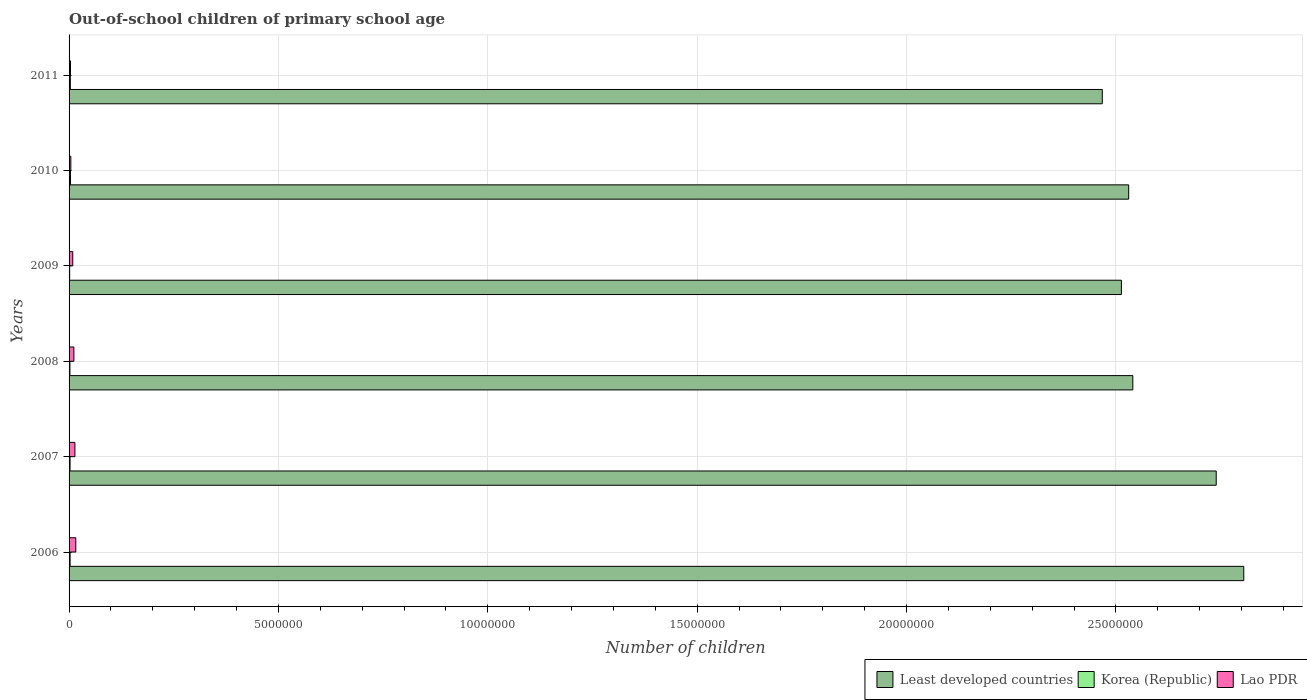Are the number of bars on each tick of the Y-axis equal?
Keep it short and to the point. Yes. How many bars are there on the 3rd tick from the bottom?
Provide a succinct answer. 3. What is the label of the 5th group of bars from the top?
Give a very brief answer. 2007. In how many cases, is the number of bars for a given year not equal to the number of legend labels?
Keep it short and to the point. 0. What is the number of out-of-school children in Korea (Republic) in 2007?
Provide a succinct answer. 2.36e+04. Across all years, what is the maximum number of out-of-school children in Korea (Republic)?
Give a very brief answer. 3.47e+04. Across all years, what is the minimum number of out-of-school children in Least developed countries?
Ensure brevity in your answer.  2.47e+07. What is the total number of out-of-school children in Least developed countries in the graph?
Keep it short and to the point. 1.56e+08. What is the difference between the number of out-of-school children in Least developed countries in 2006 and that in 2011?
Offer a terse response. 3.38e+06. What is the difference between the number of out-of-school children in Lao PDR in 2006 and the number of out-of-school children in Korea (Republic) in 2011?
Make the answer very short. 1.30e+05. What is the average number of out-of-school children in Lao PDR per year?
Make the answer very short. 9.64e+04. In the year 2006, what is the difference between the number of out-of-school children in Least developed countries and number of out-of-school children in Lao PDR?
Your answer should be very brief. 2.79e+07. In how many years, is the number of out-of-school children in Korea (Republic) greater than 22000000 ?
Provide a short and direct response. 0. What is the ratio of the number of out-of-school children in Least developed countries in 2007 to that in 2009?
Keep it short and to the point. 1.09. What is the difference between the highest and the second highest number of out-of-school children in Least developed countries?
Provide a succinct answer. 6.58e+05. What is the difference between the highest and the lowest number of out-of-school children in Least developed countries?
Your response must be concise. 3.38e+06. In how many years, is the number of out-of-school children in Korea (Republic) greater than the average number of out-of-school children in Korea (Republic) taken over all years?
Give a very brief answer. 3. What does the 1st bar from the top in 2006 represents?
Offer a very short reply. Lao PDR. Are all the bars in the graph horizontal?
Ensure brevity in your answer.  Yes. Are the values on the major ticks of X-axis written in scientific E-notation?
Offer a terse response. No. Does the graph contain any zero values?
Make the answer very short. No. Does the graph contain grids?
Your answer should be very brief. Yes. Where does the legend appear in the graph?
Offer a terse response. Bottom right. What is the title of the graph?
Your answer should be compact. Out-of-school children of primary school age. What is the label or title of the X-axis?
Ensure brevity in your answer.  Number of children. What is the Number of children in Least developed countries in 2006?
Provide a succinct answer. 2.81e+07. What is the Number of children in Korea (Republic) in 2006?
Provide a short and direct response. 2.47e+04. What is the Number of children in Lao PDR in 2006?
Provide a short and direct response. 1.61e+05. What is the Number of children of Least developed countries in 2007?
Offer a terse response. 2.74e+07. What is the Number of children of Korea (Republic) in 2007?
Keep it short and to the point. 2.36e+04. What is the Number of children in Lao PDR in 2007?
Keep it short and to the point. 1.39e+05. What is the Number of children of Least developed countries in 2008?
Ensure brevity in your answer.  2.54e+07. What is the Number of children of Korea (Republic) in 2008?
Offer a terse response. 1.99e+04. What is the Number of children of Lao PDR in 2008?
Provide a short and direct response. 1.15e+05. What is the Number of children in Least developed countries in 2009?
Your answer should be very brief. 2.51e+07. What is the Number of children in Korea (Republic) in 2009?
Make the answer very short. 1.38e+04. What is the Number of children of Lao PDR in 2009?
Give a very brief answer. 8.77e+04. What is the Number of children in Least developed countries in 2010?
Provide a short and direct response. 2.53e+07. What is the Number of children of Korea (Republic) in 2010?
Offer a terse response. 3.47e+04. What is the Number of children in Lao PDR in 2010?
Ensure brevity in your answer.  4.20e+04. What is the Number of children of Least developed countries in 2011?
Offer a very short reply. 2.47e+07. What is the Number of children in Korea (Republic) in 2011?
Provide a succinct answer. 3.04e+04. What is the Number of children of Lao PDR in 2011?
Offer a terse response. 3.39e+04. Across all years, what is the maximum Number of children of Least developed countries?
Make the answer very short. 2.81e+07. Across all years, what is the maximum Number of children in Korea (Republic)?
Give a very brief answer. 3.47e+04. Across all years, what is the maximum Number of children of Lao PDR?
Provide a succinct answer. 1.61e+05. Across all years, what is the minimum Number of children of Least developed countries?
Your answer should be very brief. 2.47e+07. Across all years, what is the minimum Number of children of Korea (Republic)?
Offer a very short reply. 1.38e+04. Across all years, what is the minimum Number of children of Lao PDR?
Provide a succinct answer. 3.39e+04. What is the total Number of children of Least developed countries in the graph?
Give a very brief answer. 1.56e+08. What is the total Number of children of Korea (Republic) in the graph?
Your response must be concise. 1.47e+05. What is the total Number of children of Lao PDR in the graph?
Give a very brief answer. 5.78e+05. What is the difference between the Number of children in Least developed countries in 2006 and that in 2007?
Your answer should be compact. 6.58e+05. What is the difference between the Number of children in Korea (Republic) in 2006 and that in 2007?
Provide a short and direct response. 1090. What is the difference between the Number of children in Lao PDR in 2006 and that in 2007?
Provide a succinct answer. 2.13e+04. What is the difference between the Number of children in Least developed countries in 2006 and that in 2008?
Make the answer very short. 2.65e+06. What is the difference between the Number of children of Korea (Republic) in 2006 and that in 2008?
Offer a terse response. 4780. What is the difference between the Number of children in Lao PDR in 2006 and that in 2008?
Your answer should be compact. 4.56e+04. What is the difference between the Number of children of Least developed countries in 2006 and that in 2009?
Offer a very short reply. 2.92e+06. What is the difference between the Number of children in Korea (Republic) in 2006 and that in 2009?
Offer a very short reply. 1.09e+04. What is the difference between the Number of children in Lao PDR in 2006 and that in 2009?
Your response must be concise. 7.28e+04. What is the difference between the Number of children of Least developed countries in 2006 and that in 2010?
Give a very brief answer. 2.75e+06. What is the difference between the Number of children of Korea (Republic) in 2006 and that in 2010?
Ensure brevity in your answer.  -1.00e+04. What is the difference between the Number of children of Lao PDR in 2006 and that in 2010?
Provide a short and direct response. 1.19e+05. What is the difference between the Number of children in Least developed countries in 2006 and that in 2011?
Offer a very short reply. 3.38e+06. What is the difference between the Number of children of Korea (Republic) in 2006 and that in 2011?
Keep it short and to the point. -5786. What is the difference between the Number of children of Lao PDR in 2006 and that in 2011?
Offer a very short reply. 1.27e+05. What is the difference between the Number of children of Least developed countries in 2007 and that in 2008?
Provide a short and direct response. 1.99e+06. What is the difference between the Number of children of Korea (Republic) in 2007 and that in 2008?
Your response must be concise. 3690. What is the difference between the Number of children in Lao PDR in 2007 and that in 2008?
Provide a succinct answer. 2.43e+04. What is the difference between the Number of children of Least developed countries in 2007 and that in 2009?
Ensure brevity in your answer.  2.26e+06. What is the difference between the Number of children of Korea (Republic) in 2007 and that in 2009?
Provide a succinct answer. 9817. What is the difference between the Number of children in Lao PDR in 2007 and that in 2009?
Your answer should be compact. 5.16e+04. What is the difference between the Number of children of Least developed countries in 2007 and that in 2010?
Ensure brevity in your answer.  2.09e+06. What is the difference between the Number of children in Korea (Republic) in 2007 and that in 2010?
Keep it short and to the point. -1.11e+04. What is the difference between the Number of children of Lao PDR in 2007 and that in 2010?
Offer a terse response. 9.72e+04. What is the difference between the Number of children of Least developed countries in 2007 and that in 2011?
Ensure brevity in your answer.  2.72e+06. What is the difference between the Number of children of Korea (Republic) in 2007 and that in 2011?
Your response must be concise. -6876. What is the difference between the Number of children of Lao PDR in 2007 and that in 2011?
Offer a very short reply. 1.05e+05. What is the difference between the Number of children of Least developed countries in 2008 and that in 2009?
Your answer should be very brief. 2.73e+05. What is the difference between the Number of children in Korea (Republic) in 2008 and that in 2009?
Provide a succinct answer. 6127. What is the difference between the Number of children of Lao PDR in 2008 and that in 2009?
Your answer should be very brief. 2.73e+04. What is the difference between the Number of children of Least developed countries in 2008 and that in 2010?
Ensure brevity in your answer.  9.95e+04. What is the difference between the Number of children of Korea (Republic) in 2008 and that in 2010?
Provide a short and direct response. -1.48e+04. What is the difference between the Number of children in Lao PDR in 2008 and that in 2010?
Offer a very short reply. 7.29e+04. What is the difference between the Number of children of Least developed countries in 2008 and that in 2011?
Your response must be concise. 7.30e+05. What is the difference between the Number of children of Korea (Republic) in 2008 and that in 2011?
Your answer should be compact. -1.06e+04. What is the difference between the Number of children in Lao PDR in 2008 and that in 2011?
Your response must be concise. 8.10e+04. What is the difference between the Number of children of Least developed countries in 2009 and that in 2010?
Provide a succinct answer. -1.74e+05. What is the difference between the Number of children in Korea (Republic) in 2009 and that in 2010?
Offer a terse response. -2.09e+04. What is the difference between the Number of children in Lao PDR in 2009 and that in 2010?
Your answer should be very brief. 4.57e+04. What is the difference between the Number of children in Least developed countries in 2009 and that in 2011?
Give a very brief answer. 4.56e+05. What is the difference between the Number of children in Korea (Republic) in 2009 and that in 2011?
Provide a short and direct response. -1.67e+04. What is the difference between the Number of children of Lao PDR in 2009 and that in 2011?
Offer a very short reply. 5.37e+04. What is the difference between the Number of children of Least developed countries in 2010 and that in 2011?
Make the answer very short. 6.30e+05. What is the difference between the Number of children of Korea (Republic) in 2010 and that in 2011?
Ensure brevity in your answer.  4226. What is the difference between the Number of children in Lao PDR in 2010 and that in 2011?
Provide a succinct answer. 8078. What is the difference between the Number of children in Least developed countries in 2006 and the Number of children in Korea (Republic) in 2007?
Offer a terse response. 2.80e+07. What is the difference between the Number of children in Least developed countries in 2006 and the Number of children in Lao PDR in 2007?
Your answer should be very brief. 2.79e+07. What is the difference between the Number of children of Korea (Republic) in 2006 and the Number of children of Lao PDR in 2007?
Provide a succinct answer. -1.15e+05. What is the difference between the Number of children of Least developed countries in 2006 and the Number of children of Korea (Republic) in 2008?
Your response must be concise. 2.80e+07. What is the difference between the Number of children in Least developed countries in 2006 and the Number of children in Lao PDR in 2008?
Offer a very short reply. 2.79e+07. What is the difference between the Number of children of Korea (Republic) in 2006 and the Number of children of Lao PDR in 2008?
Keep it short and to the point. -9.03e+04. What is the difference between the Number of children in Least developed countries in 2006 and the Number of children in Korea (Republic) in 2009?
Your response must be concise. 2.80e+07. What is the difference between the Number of children in Least developed countries in 2006 and the Number of children in Lao PDR in 2009?
Offer a very short reply. 2.80e+07. What is the difference between the Number of children of Korea (Republic) in 2006 and the Number of children of Lao PDR in 2009?
Give a very brief answer. -6.30e+04. What is the difference between the Number of children in Least developed countries in 2006 and the Number of children in Korea (Republic) in 2010?
Your answer should be compact. 2.80e+07. What is the difference between the Number of children of Least developed countries in 2006 and the Number of children of Lao PDR in 2010?
Ensure brevity in your answer.  2.80e+07. What is the difference between the Number of children in Korea (Republic) in 2006 and the Number of children in Lao PDR in 2010?
Provide a succinct answer. -1.74e+04. What is the difference between the Number of children of Least developed countries in 2006 and the Number of children of Korea (Republic) in 2011?
Offer a terse response. 2.80e+07. What is the difference between the Number of children of Least developed countries in 2006 and the Number of children of Lao PDR in 2011?
Your answer should be compact. 2.80e+07. What is the difference between the Number of children in Korea (Republic) in 2006 and the Number of children in Lao PDR in 2011?
Offer a very short reply. -9288. What is the difference between the Number of children of Least developed countries in 2007 and the Number of children of Korea (Republic) in 2008?
Your answer should be compact. 2.74e+07. What is the difference between the Number of children of Least developed countries in 2007 and the Number of children of Lao PDR in 2008?
Provide a succinct answer. 2.73e+07. What is the difference between the Number of children in Korea (Republic) in 2007 and the Number of children in Lao PDR in 2008?
Your answer should be very brief. -9.14e+04. What is the difference between the Number of children of Least developed countries in 2007 and the Number of children of Korea (Republic) in 2009?
Give a very brief answer. 2.74e+07. What is the difference between the Number of children of Least developed countries in 2007 and the Number of children of Lao PDR in 2009?
Your answer should be compact. 2.73e+07. What is the difference between the Number of children of Korea (Republic) in 2007 and the Number of children of Lao PDR in 2009?
Give a very brief answer. -6.41e+04. What is the difference between the Number of children in Least developed countries in 2007 and the Number of children in Korea (Republic) in 2010?
Make the answer very short. 2.74e+07. What is the difference between the Number of children in Least developed countries in 2007 and the Number of children in Lao PDR in 2010?
Your answer should be very brief. 2.74e+07. What is the difference between the Number of children in Korea (Republic) in 2007 and the Number of children in Lao PDR in 2010?
Your answer should be compact. -1.85e+04. What is the difference between the Number of children in Least developed countries in 2007 and the Number of children in Korea (Republic) in 2011?
Provide a short and direct response. 2.74e+07. What is the difference between the Number of children of Least developed countries in 2007 and the Number of children of Lao PDR in 2011?
Keep it short and to the point. 2.74e+07. What is the difference between the Number of children of Korea (Republic) in 2007 and the Number of children of Lao PDR in 2011?
Keep it short and to the point. -1.04e+04. What is the difference between the Number of children in Least developed countries in 2008 and the Number of children in Korea (Republic) in 2009?
Keep it short and to the point. 2.54e+07. What is the difference between the Number of children in Least developed countries in 2008 and the Number of children in Lao PDR in 2009?
Keep it short and to the point. 2.53e+07. What is the difference between the Number of children of Korea (Republic) in 2008 and the Number of children of Lao PDR in 2009?
Provide a short and direct response. -6.78e+04. What is the difference between the Number of children of Least developed countries in 2008 and the Number of children of Korea (Republic) in 2010?
Your answer should be very brief. 2.54e+07. What is the difference between the Number of children in Least developed countries in 2008 and the Number of children in Lao PDR in 2010?
Your answer should be compact. 2.54e+07. What is the difference between the Number of children of Korea (Republic) in 2008 and the Number of children of Lao PDR in 2010?
Offer a very short reply. -2.21e+04. What is the difference between the Number of children in Least developed countries in 2008 and the Number of children in Korea (Republic) in 2011?
Ensure brevity in your answer.  2.54e+07. What is the difference between the Number of children in Least developed countries in 2008 and the Number of children in Lao PDR in 2011?
Your answer should be very brief. 2.54e+07. What is the difference between the Number of children of Korea (Republic) in 2008 and the Number of children of Lao PDR in 2011?
Ensure brevity in your answer.  -1.41e+04. What is the difference between the Number of children of Least developed countries in 2009 and the Number of children of Korea (Republic) in 2010?
Your response must be concise. 2.51e+07. What is the difference between the Number of children in Least developed countries in 2009 and the Number of children in Lao PDR in 2010?
Provide a short and direct response. 2.51e+07. What is the difference between the Number of children in Korea (Republic) in 2009 and the Number of children in Lao PDR in 2010?
Offer a very short reply. -2.83e+04. What is the difference between the Number of children of Least developed countries in 2009 and the Number of children of Korea (Republic) in 2011?
Make the answer very short. 2.51e+07. What is the difference between the Number of children of Least developed countries in 2009 and the Number of children of Lao PDR in 2011?
Your answer should be very brief. 2.51e+07. What is the difference between the Number of children in Korea (Republic) in 2009 and the Number of children in Lao PDR in 2011?
Your answer should be compact. -2.02e+04. What is the difference between the Number of children of Least developed countries in 2010 and the Number of children of Korea (Republic) in 2011?
Provide a short and direct response. 2.53e+07. What is the difference between the Number of children in Least developed countries in 2010 and the Number of children in Lao PDR in 2011?
Give a very brief answer. 2.53e+07. What is the difference between the Number of children in Korea (Republic) in 2010 and the Number of children in Lao PDR in 2011?
Make the answer very short. 724. What is the average Number of children of Least developed countries per year?
Offer a very short reply. 2.60e+07. What is the average Number of children of Korea (Republic) per year?
Offer a very short reply. 2.45e+04. What is the average Number of children in Lao PDR per year?
Ensure brevity in your answer.  9.64e+04. In the year 2006, what is the difference between the Number of children of Least developed countries and Number of children of Korea (Republic)?
Provide a short and direct response. 2.80e+07. In the year 2006, what is the difference between the Number of children in Least developed countries and Number of children in Lao PDR?
Provide a succinct answer. 2.79e+07. In the year 2006, what is the difference between the Number of children of Korea (Republic) and Number of children of Lao PDR?
Offer a very short reply. -1.36e+05. In the year 2007, what is the difference between the Number of children in Least developed countries and Number of children in Korea (Republic)?
Your answer should be compact. 2.74e+07. In the year 2007, what is the difference between the Number of children of Least developed countries and Number of children of Lao PDR?
Keep it short and to the point. 2.73e+07. In the year 2007, what is the difference between the Number of children of Korea (Republic) and Number of children of Lao PDR?
Your response must be concise. -1.16e+05. In the year 2008, what is the difference between the Number of children of Least developed countries and Number of children of Korea (Republic)?
Keep it short and to the point. 2.54e+07. In the year 2008, what is the difference between the Number of children of Least developed countries and Number of children of Lao PDR?
Give a very brief answer. 2.53e+07. In the year 2008, what is the difference between the Number of children of Korea (Republic) and Number of children of Lao PDR?
Give a very brief answer. -9.51e+04. In the year 2009, what is the difference between the Number of children of Least developed countries and Number of children of Korea (Republic)?
Make the answer very short. 2.51e+07. In the year 2009, what is the difference between the Number of children of Least developed countries and Number of children of Lao PDR?
Your answer should be compact. 2.50e+07. In the year 2009, what is the difference between the Number of children of Korea (Republic) and Number of children of Lao PDR?
Offer a terse response. -7.39e+04. In the year 2010, what is the difference between the Number of children in Least developed countries and Number of children in Korea (Republic)?
Keep it short and to the point. 2.53e+07. In the year 2010, what is the difference between the Number of children in Least developed countries and Number of children in Lao PDR?
Your response must be concise. 2.53e+07. In the year 2010, what is the difference between the Number of children of Korea (Republic) and Number of children of Lao PDR?
Keep it short and to the point. -7354. In the year 2011, what is the difference between the Number of children in Least developed countries and Number of children in Korea (Republic)?
Offer a very short reply. 2.46e+07. In the year 2011, what is the difference between the Number of children in Least developed countries and Number of children in Lao PDR?
Provide a succinct answer. 2.46e+07. In the year 2011, what is the difference between the Number of children of Korea (Republic) and Number of children of Lao PDR?
Give a very brief answer. -3502. What is the ratio of the Number of children of Least developed countries in 2006 to that in 2007?
Offer a very short reply. 1.02. What is the ratio of the Number of children in Korea (Republic) in 2006 to that in 2007?
Ensure brevity in your answer.  1.05. What is the ratio of the Number of children of Lao PDR in 2006 to that in 2007?
Your answer should be very brief. 1.15. What is the ratio of the Number of children in Least developed countries in 2006 to that in 2008?
Your answer should be compact. 1.1. What is the ratio of the Number of children of Korea (Republic) in 2006 to that in 2008?
Provide a short and direct response. 1.24. What is the ratio of the Number of children of Lao PDR in 2006 to that in 2008?
Provide a succinct answer. 1.4. What is the ratio of the Number of children of Least developed countries in 2006 to that in 2009?
Your answer should be very brief. 1.12. What is the ratio of the Number of children in Korea (Republic) in 2006 to that in 2009?
Your answer should be compact. 1.79. What is the ratio of the Number of children of Lao PDR in 2006 to that in 2009?
Make the answer very short. 1.83. What is the ratio of the Number of children in Least developed countries in 2006 to that in 2010?
Provide a succinct answer. 1.11. What is the ratio of the Number of children of Korea (Republic) in 2006 to that in 2010?
Ensure brevity in your answer.  0.71. What is the ratio of the Number of children of Lao PDR in 2006 to that in 2010?
Your response must be concise. 3.82. What is the ratio of the Number of children of Least developed countries in 2006 to that in 2011?
Keep it short and to the point. 1.14. What is the ratio of the Number of children in Korea (Republic) in 2006 to that in 2011?
Keep it short and to the point. 0.81. What is the ratio of the Number of children in Lao PDR in 2006 to that in 2011?
Offer a terse response. 4.73. What is the ratio of the Number of children of Least developed countries in 2007 to that in 2008?
Offer a terse response. 1.08. What is the ratio of the Number of children of Korea (Republic) in 2007 to that in 2008?
Provide a succinct answer. 1.19. What is the ratio of the Number of children in Lao PDR in 2007 to that in 2008?
Ensure brevity in your answer.  1.21. What is the ratio of the Number of children in Least developed countries in 2007 to that in 2009?
Keep it short and to the point. 1.09. What is the ratio of the Number of children of Korea (Republic) in 2007 to that in 2009?
Offer a terse response. 1.71. What is the ratio of the Number of children in Lao PDR in 2007 to that in 2009?
Your answer should be compact. 1.59. What is the ratio of the Number of children in Least developed countries in 2007 to that in 2010?
Keep it short and to the point. 1.08. What is the ratio of the Number of children of Korea (Republic) in 2007 to that in 2010?
Offer a terse response. 0.68. What is the ratio of the Number of children in Lao PDR in 2007 to that in 2010?
Your answer should be compact. 3.31. What is the ratio of the Number of children in Least developed countries in 2007 to that in 2011?
Provide a short and direct response. 1.11. What is the ratio of the Number of children in Korea (Republic) in 2007 to that in 2011?
Provide a short and direct response. 0.77. What is the ratio of the Number of children of Lao PDR in 2007 to that in 2011?
Give a very brief answer. 4.1. What is the ratio of the Number of children of Least developed countries in 2008 to that in 2009?
Keep it short and to the point. 1.01. What is the ratio of the Number of children of Korea (Republic) in 2008 to that in 2009?
Your answer should be compact. 1.45. What is the ratio of the Number of children in Lao PDR in 2008 to that in 2009?
Make the answer very short. 1.31. What is the ratio of the Number of children of Least developed countries in 2008 to that in 2010?
Ensure brevity in your answer.  1. What is the ratio of the Number of children in Korea (Republic) in 2008 to that in 2010?
Ensure brevity in your answer.  0.57. What is the ratio of the Number of children in Lao PDR in 2008 to that in 2010?
Ensure brevity in your answer.  2.74. What is the ratio of the Number of children of Least developed countries in 2008 to that in 2011?
Offer a very short reply. 1.03. What is the ratio of the Number of children of Korea (Republic) in 2008 to that in 2011?
Provide a succinct answer. 0.65. What is the ratio of the Number of children of Lao PDR in 2008 to that in 2011?
Your answer should be very brief. 3.39. What is the ratio of the Number of children in Least developed countries in 2009 to that in 2010?
Your response must be concise. 0.99. What is the ratio of the Number of children of Korea (Republic) in 2009 to that in 2010?
Your answer should be compact. 0.4. What is the ratio of the Number of children in Lao PDR in 2009 to that in 2010?
Your answer should be very brief. 2.09. What is the ratio of the Number of children of Least developed countries in 2009 to that in 2011?
Provide a short and direct response. 1.02. What is the ratio of the Number of children in Korea (Republic) in 2009 to that in 2011?
Offer a very short reply. 0.45. What is the ratio of the Number of children in Lao PDR in 2009 to that in 2011?
Ensure brevity in your answer.  2.58. What is the ratio of the Number of children of Least developed countries in 2010 to that in 2011?
Offer a terse response. 1.03. What is the ratio of the Number of children in Korea (Republic) in 2010 to that in 2011?
Your answer should be very brief. 1.14. What is the ratio of the Number of children in Lao PDR in 2010 to that in 2011?
Offer a very short reply. 1.24. What is the difference between the highest and the second highest Number of children of Least developed countries?
Your answer should be very brief. 6.58e+05. What is the difference between the highest and the second highest Number of children of Korea (Republic)?
Offer a terse response. 4226. What is the difference between the highest and the second highest Number of children of Lao PDR?
Keep it short and to the point. 2.13e+04. What is the difference between the highest and the lowest Number of children of Least developed countries?
Provide a short and direct response. 3.38e+06. What is the difference between the highest and the lowest Number of children in Korea (Republic)?
Your answer should be very brief. 2.09e+04. What is the difference between the highest and the lowest Number of children of Lao PDR?
Make the answer very short. 1.27e+05. 